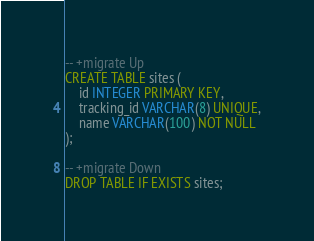<code> <loc_0><loc_0><loc_500><loc_500><_SQL_>-- +migrate Up
CREATE TABLE sites (
    id INTEGER PRIMARY KEY,
    tracking_id VARCHAR(8) UNIQUE,
    name VARCHAR(100) NOT NULL
);

-- +migrate Down
DROP TABLE IF EXISTS sites;</code> 